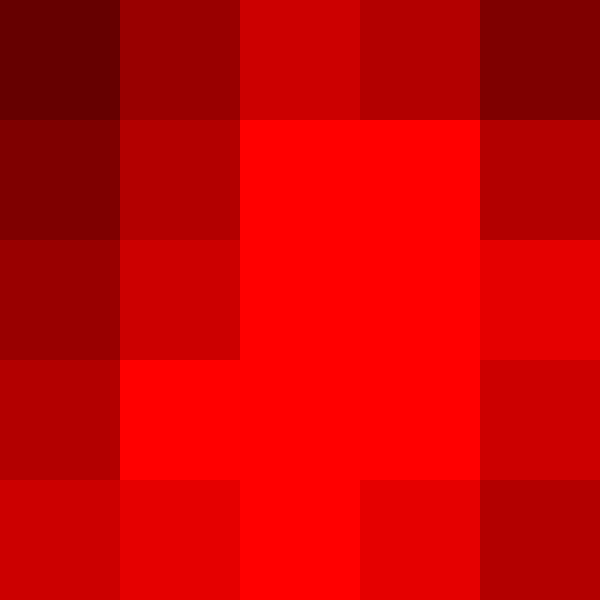Based on the heat map showing the geographical distribution of tennis courts in Australia, which region appears to have the highest concentration of tennis facilities, and how might this relate to the recent Djokovic saga? To answer this question, we need to analyze the heat map and consider its implications in the context of the Djokovic saga:

1. Interpret the heat map:
   - The map shows Australia divided into a 5x5 grid.
   - The color intensity represents the density of tennis courts, with darker red indicating higher density.

2. Identify the region with the highest concentration:
   - The darkest red area is located in the center-right portion of the map.
   - This likely corresponds to the southeastern part of Australia.

3. Relate to geography:
   - The southeastern region of Australia includes major cities like Melbourne and Sydney.
   - Melbourne, in particular, is known for hosting the Australian Open.

4. Connect to the Djokovic saga:
   - Novak Djokovic's controversy was centered around his participation in the Australian Open in Melbourne.
   - The high concentration of tennis courts in this region suggests a strong tennis culture and infrastructure.

5. Implications:
   - The density of courts might explain why the Djokovic issue became so significant in this area.
   - It reflects the importance of tennis to the local community and economy.

6. National perspective:
   - As an Australian citizen, one might consider how this distribution affects national tennis development and resources allocation.
   - The concentration in one area might influence public opinion on tennis-related issues across the country.
Answer: Southeastern Australia, likely including Melbourne, has the highest concentration of tennis courts, potentially amplifying the local impact and national attention of the Djokovic saga due to the region's strong tennis culture. 